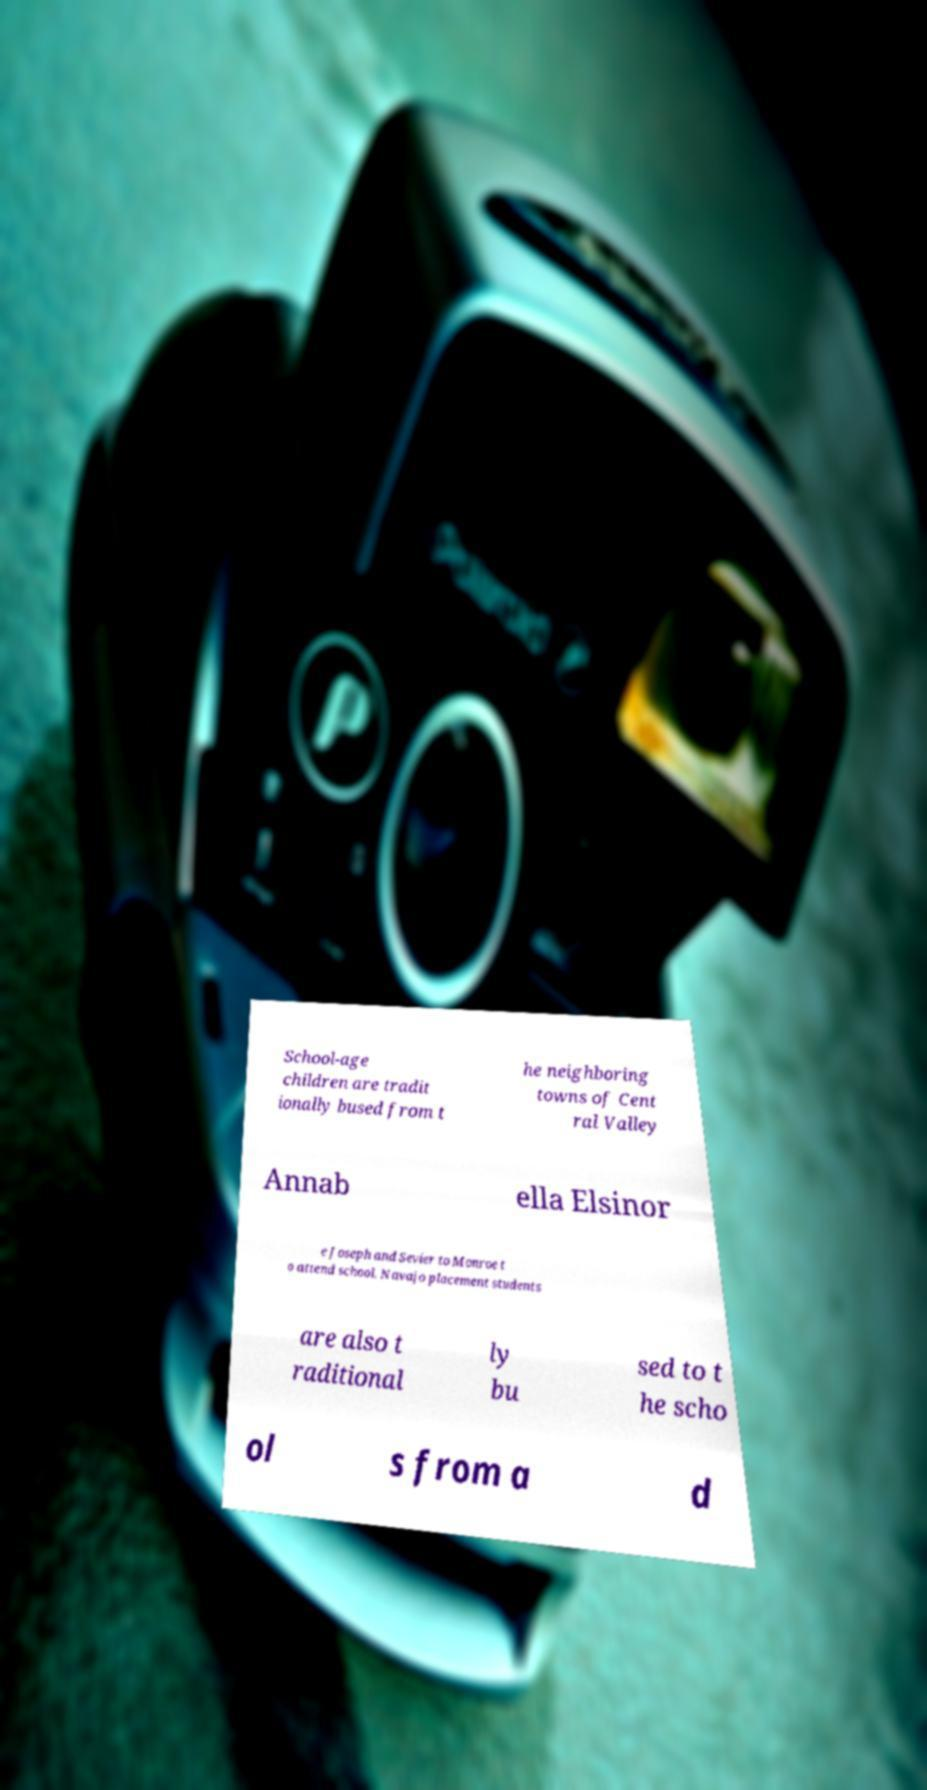Can you accurately transcribe the text from the provided image for me? School-age children are tradit ionally bused from t he neighboring towns of Cent ral Valley Annab ella Elsinor e Joseph and Sevier to Monroe t o attend school. Navajo placement students are also t raditional ly bu sed to t he scho ol s from a d 